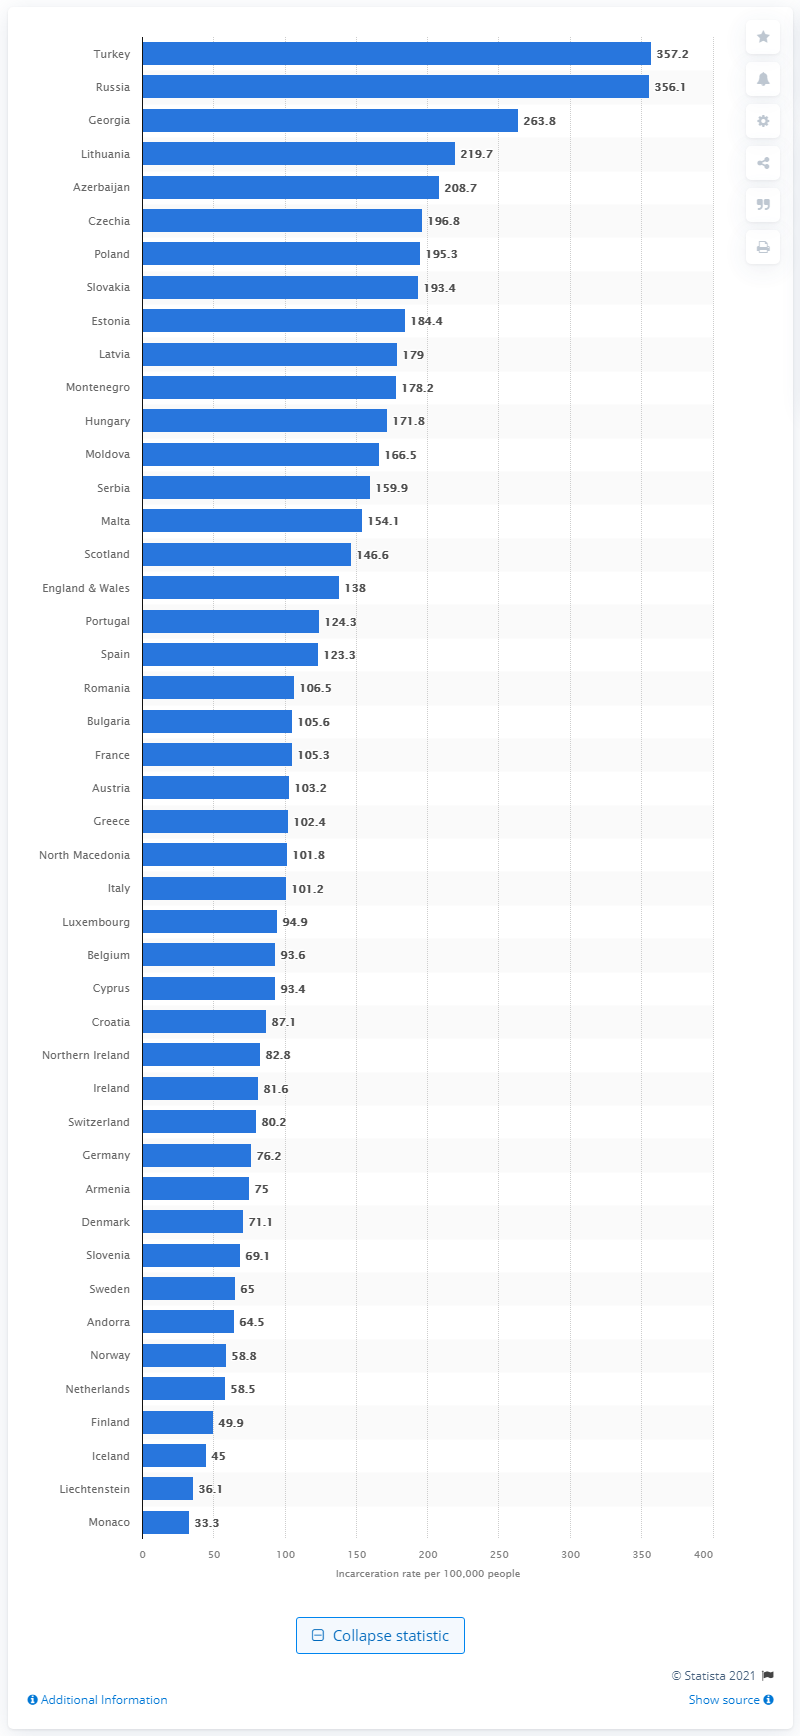Highlight a few significant elements in this photo. According to statistics, Germany had the lowest incarceration rate in 2020 among countries worldwide. According to data from 2020, Monaco had the lowest incarceration rate among all countries. 